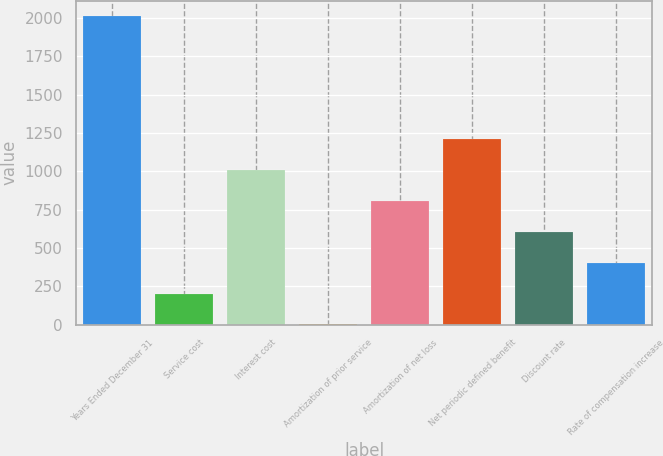Convert chart to OTSL. <chart><loc_0><loc_0><loc_500><loc_500><bar_chart><fcel>Years Ended December 31<fcel>Service cost<fcel>Interest cost<fcel>Amortization of prior service<fcel>Amortization of net loss<fcel>Net periodic defined benefit<fcel>Discount rate<fcel>Rate of compensation increase<nl><fcel>2011<fcel>202.9<fcel>1006.5<fcel>2<fcel>805.6<fcel>1207.4<fcel>604.7<fcel>403.8<nl></chart> 